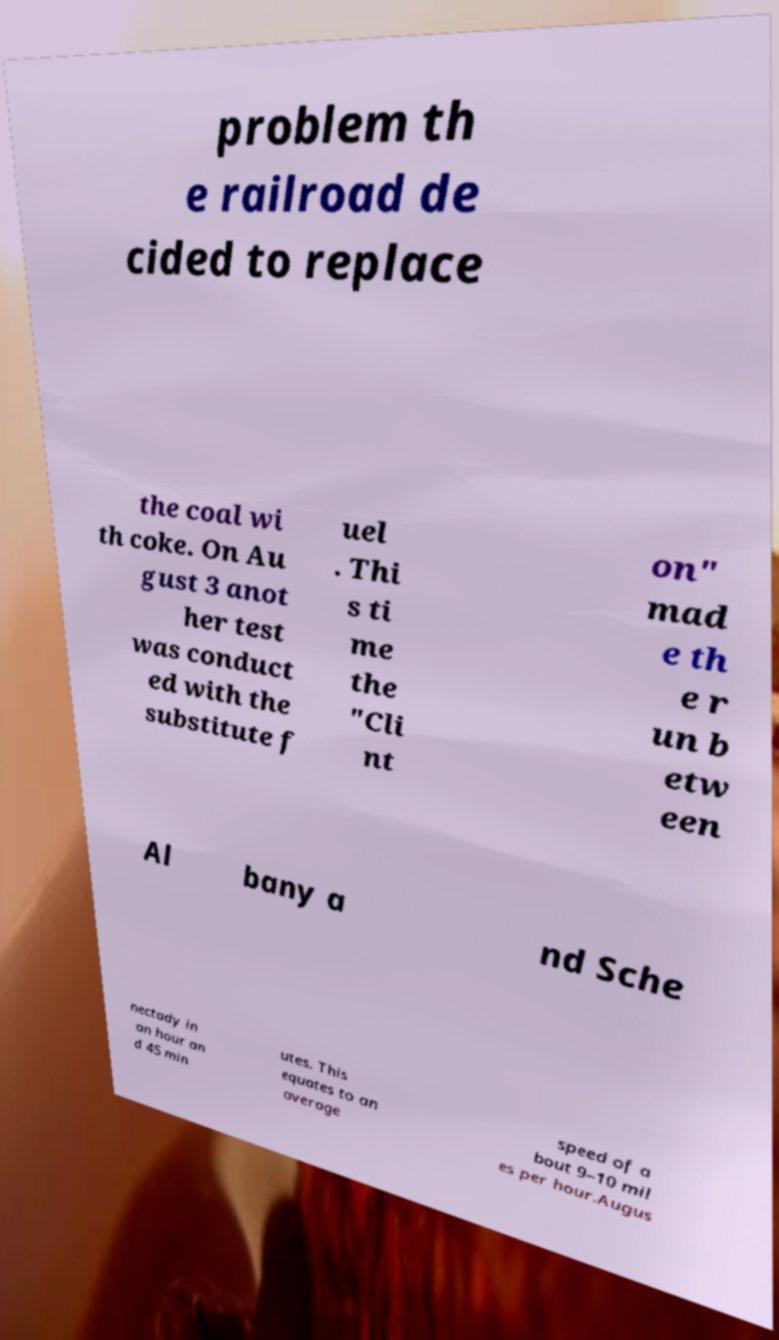There's text embedded in this image that I need extracted. Can you transcribe it verbatim? problem th e railroad de cided to replace the coal wi th coke. On Au gust 3 anot her test was conduct ed with the substitute f uel . Thi s ti me the "Cli nt on" mad e th e r un b etw een Al bany a nd Sche nectady in an hour an d 45 min utes. This equates to an average speed of a bout 9–10 mil es per hour.Augus 